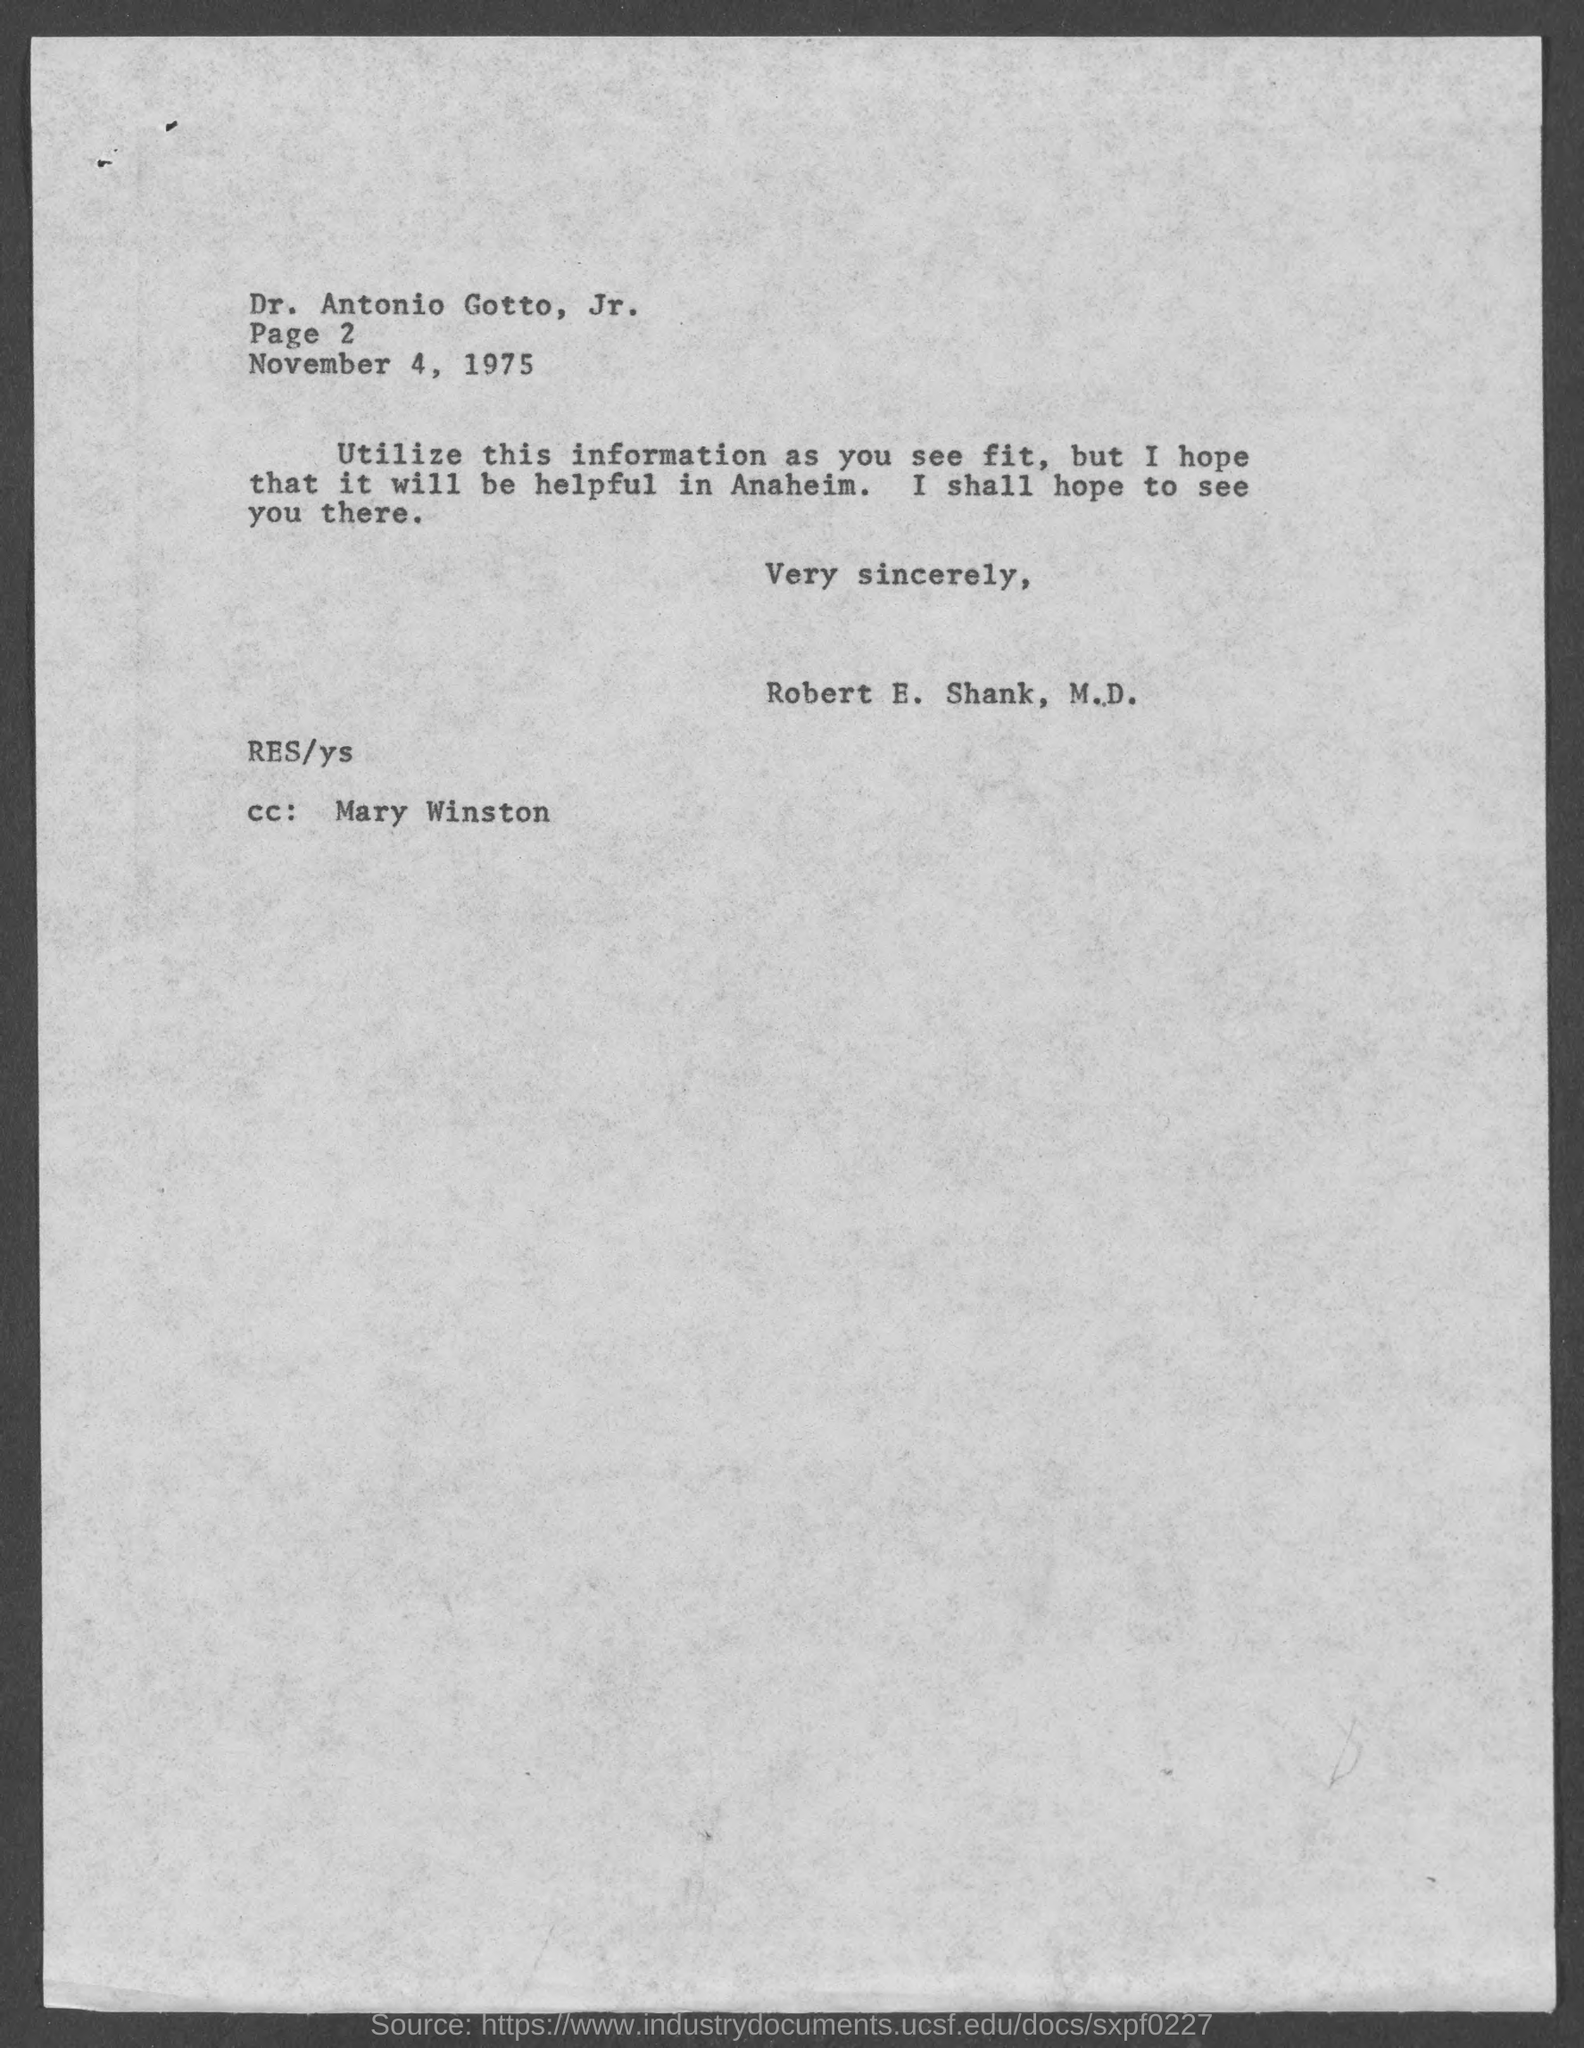Specify some key components in this picture. The addressee of this letter is Dr. Antonio Gotto, Jr. The sender of the letter is Robert E. Shank, M.D. The date mentioned in the letter is November 4, 1975. The letter mentions Mary Winston. The page number mentioned in this letter is Page 2. 